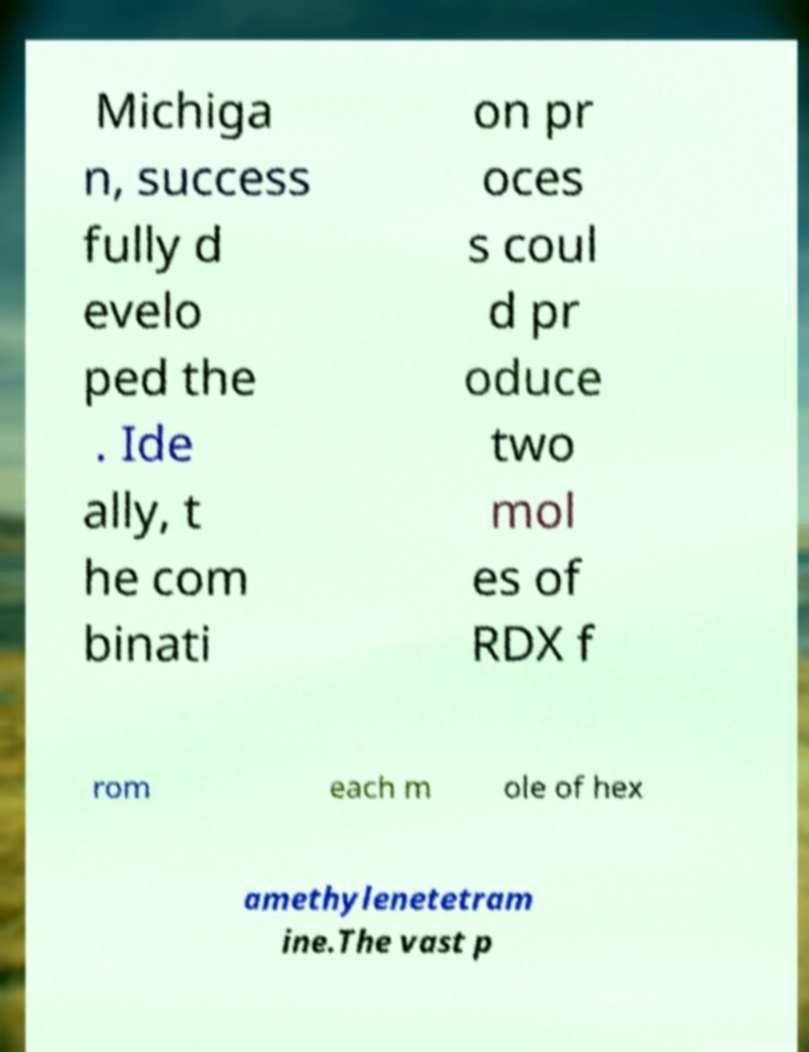Could you extract and type out the text from this image? Michiga n, success fully d evelo ped the . Ide ally, t he com binati on pr oces s coul d pr oduce two mol es of RDX f rom each m ole of hex amethylenetetram ine.The vast p 